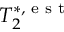<formula> <loc_0><loc_0><loc_500><loc_500>T _ { 2 } ^ { * , e s t }</formula> 